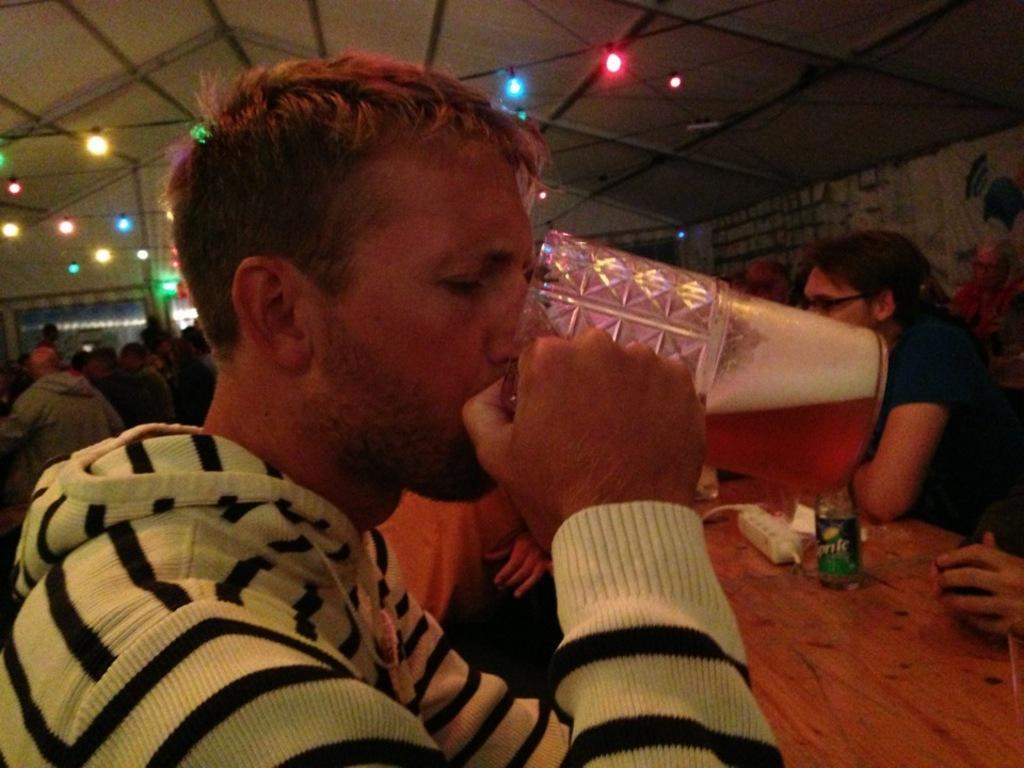Can you describe this image briefly? There is a person holding a glass and drinking. In front of him there is a table. On that there is a bottle and some other items. In the back there are many people. On the ceiling there are lights. 